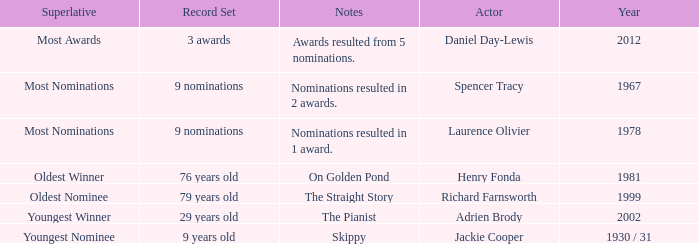What actor won in 1978? Laurence Olivier. Could you help me parse every detail presented in this table? {'header': ['Superlative', 'Record Set', 'Notes', 'Actor', 'Year'], 'rows': [['Most Awards', '3 awards', 'Awards resulted from 5 nominations.', 'Daniel Day-Lewis', '2012'], ['Most Nominations', '9 nominations', 'Nominations resulted in 2 awards.', 'Spencer Tracy', '1967'], ['Most Nominations', '9 nominations', 'Nominations resulted in 1 award.', 'Laurence Olivier', '1978'], ['Oldest Winner', '76 years old', 'On Golden Pond', 'Henry Fonda', '1981'], ['Oldest Nominee', '79 years old', 'The Straight Story', 'Richard Farnsworth', '1999'], ['Youngest Winner', '29 years old', 'The Pianist', 'Adrien Brody', '2002'], ['Youngest Nominee', '9 years old', 'Skippy', 'Jackie Cooper', '1930 / 31']]} 